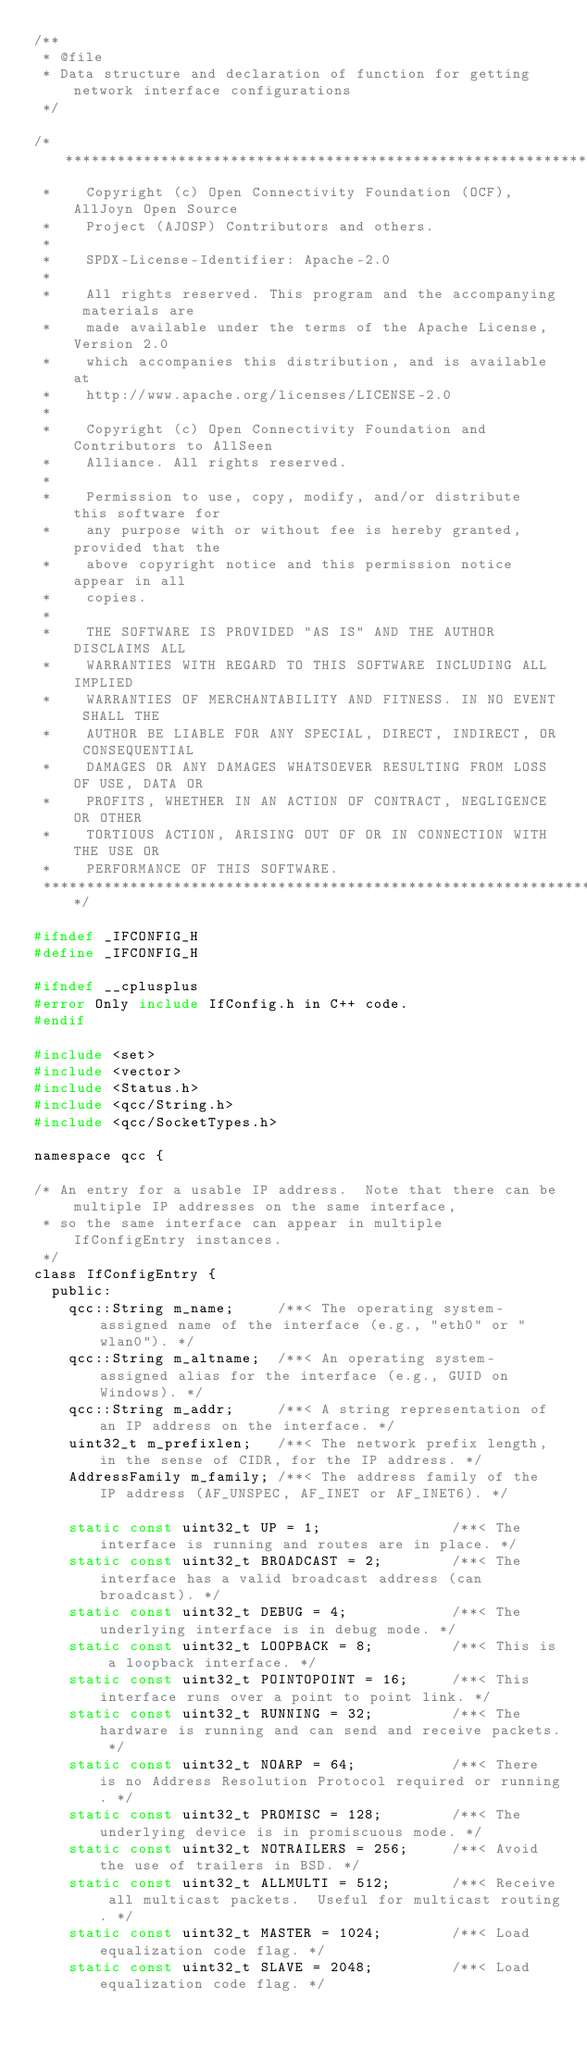<code> <loc_0><loc_0><loc_500><loc_500><_C_>/**
 * @file
 * Data structure and declaration of function for getting network interface configurations
 */

/******************************************************************************
 *    Copyright (c) Open Connectivity Foundation (OCF), AllJoyn Open Source
 *    Project (AJOSP) Contributors and others.
 *
 *    SPDX-License-Identifier: Apache-2.0
 *
 *    All rights reserved. This program and the accompanying materials are
 *    made available under the terms of the Apache License, Version 2.0
 *    which accompanies this distribution, and is available at
 *    http://www.apache.org/licenses/LICENSE-2.0
 *
 *    Copyright (c) Open Connectivity Foundation and Contributors to AllSeen
 *    Alliance. All rights reserved.
 *
 *    Permission to use, copy, modify, and/or distribute this software for
 *    any purpose with or without fee is hereby granted, provided that the
 *    above copyright notice and this permission notice appear in all
 *    copies.
 *
 *    THE SOFTWARE IS PROVIDED "AS IS" AND THE AUTHOR DISCLAIMS ALL
 *    WARRANTIES WITH REGARD TO THIS SOFTWARE INCLUDING ALL IMPLIED
 *    WARRANTIES OF MERCHANTABILITY AND FITNESS. IN NO EVENT SHALL THE
 *    AUTHOR BE LIABLE FOR ANY SPECIAL, DIRECT, INDIRECT, OR CONSEQUENTIAL
 *    DAMAGES OR ANY DAMAGES WHATSOEVER RESULTING FROM LOSS OF USE, DATA OR
 *    PROFITS, WHETHER IN AN ACTION OF CONTRACT, NEGLIGENCE OR OTHER
 *    TORTIOUS ACTION, ARISING OUT OF OR IN CONNECTION WITH THE USE OR
 *    PERFORMANCE OF THIS SOFTWARE.
 ******************************************************************************/

#ifndef _IFCONFIG_H
#define _IFCONFIG_H

#ifndef __cplusplus
#error Only include IfConfig.h in C++ code.
#endif

#include <set>
#include <vector>
#include <Status.h>
#include <qcc/String.h>
#include <qcc/SocketTypes.h>

namespace qcc {

/* An entry for a usable IP address.  Note that there can be multiple IP addresses on the same interface,
 * so the same interface can appear in multiple IfConfigEntry instances.
 */
class IfConfigEntry {
  public:
    qcc::String m_name;     /**< The operating system-assigned name of the interface (e.g., "eth0" or "wlan0"). */
    qcc::String m_altname;  /**< An operating system-assigned alias for the interface (e.g., GUID on Windows). */
    qcc::String m_addr;     /**< A string representation of an IP address on the interface. */
    uint32_t m_prefixlen;   /**< The network prefix length, in the sense of CIDR, for the IP address. */
    AddressFamily m_family; /**< The address family of the IP address (AF_UNSPEC, AF_INET or AF_INET6). */

    static const uint32_t UP = 1;               /**< The interface is running and routes are in place. */
    static const uint32_t BROADCAST = 2;        /**< The interface has a valid broadcast address (can broadcast). */
    static const uint32_t DEBUG = 4;            /**< The underlying interface is in debug mode. */
    static const uint32_t LOOPBACK = 8;         /**< This is a loopback interface. */
    static const uint32_t POINTOPOINT = 16;     /**< This interface runs over a point to point link. */
    static const uint32_t RUNNING = 32;         /**< The hardware is running and can send and receive packets. */
    static const uint32_t NOARP = 64;           /**< There is no Address Resolution Protocol required or running. */
    static const uint32_t PROMISC = 128;        /**< The underlying device is in promiscuous mode. */
    static const uint32_t NOTRAILERS = 256;     /**< Avoid the use of trailers in BSD. */
    static const uint32_t ALLMULTI = 512;       /**< Receive all multicast packets.  Useful for multicast routing. */
    static const uint32_t MASTER = 1024;        /**< Load equalization code flag. */
    static const uint32_t SLAVE = 2048;         /**< Load equalization code flag. */</code> 